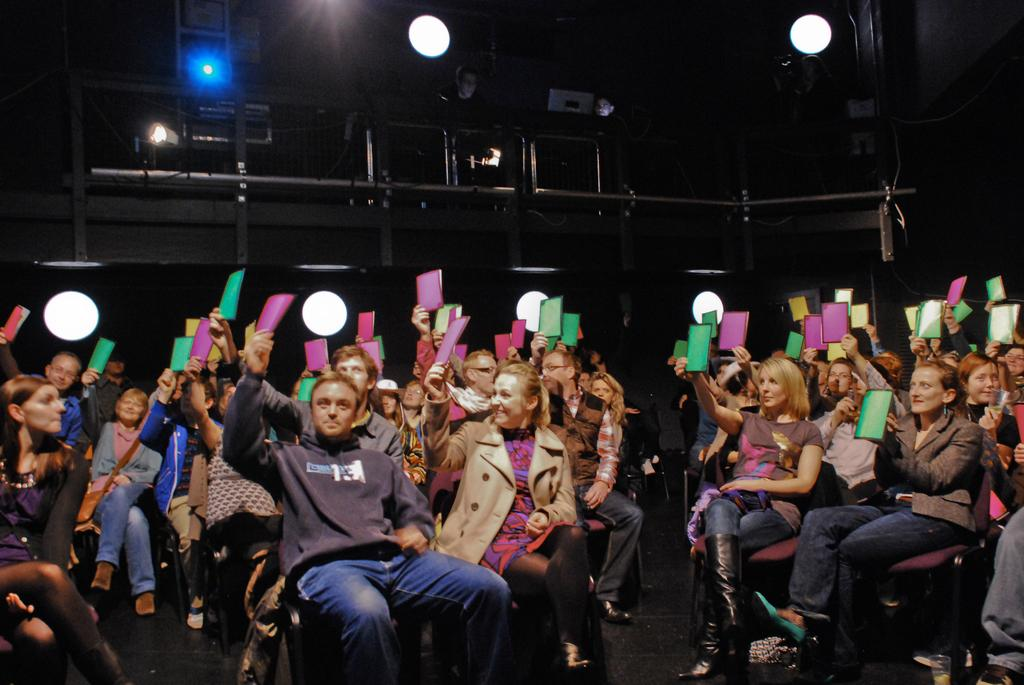How many people are in the image? There is a group of people in the image. What are the people doing in the image? The people are seated on chairs. What are the people holding in the image? The people are holding objects. What can be seen in the background of the image? There are lights visible in the background of the image. How many basketballs are being measured by the people in the image? There is no mention of basketballs or measuring in the image. The people are simply seated and holding objects. 